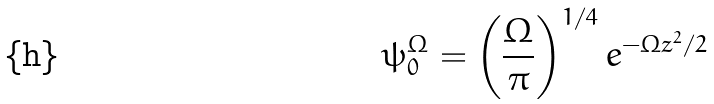<formula> <loc_0><loc_0><loc_500><loc_500>\psi _ { 0 } ^ { \Omega } = \left ( \frac { \Omega } { \pi } \right ) ^ { 1 / 4 } e ^ { - \Omega z ^ { 2 } / 2 }</formula> 